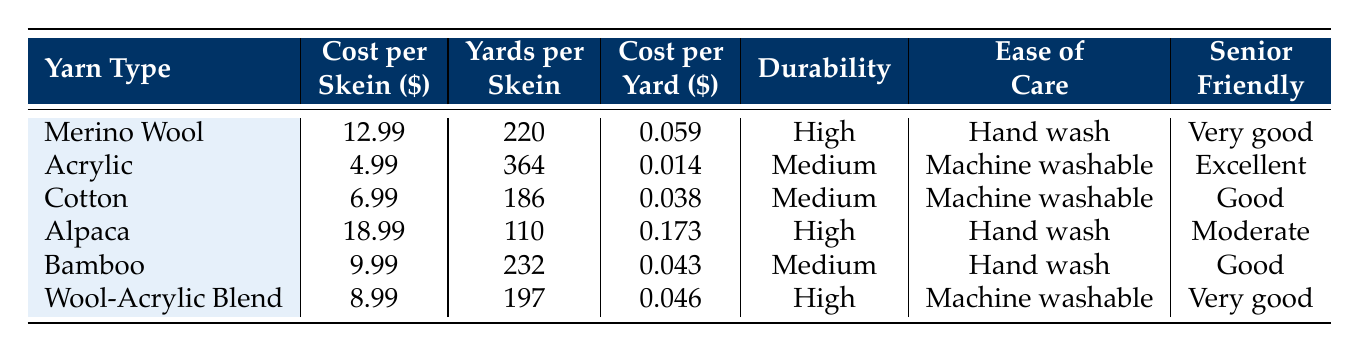What is the cost per skein of Merino Wool? The table lists the cost per skein of Merino Wool as 12.99.
Answer: 12.99 Which yarn type has the highest cost per yard? To determine the highest cost per yard, we can compare the cost per yard for all yarn types listed in the table. Alpaca has the highest cost per yard at 0.173.
Answer: Alpaca How many yards does a skein of Acrylic provide? Directly from the table, it states that a skein of Acrylic provides 364 yards.
Answer: 364 Is Bamboo less durable than Merino Wool? The durability of Bamboo is rated as Medium, while Merino Wool is rated as High. Therefore, Bamboo is indeed less durable than Merino Wool.
Answer: Yes What is the average cost per skein for the yarn types listed? To find the average cost per skein, we first sum the costs: (12.99 + 4.99 + 6.99 + 18.99 + 9.99 + 8.99) = 61.94, then divide by the number of yarn types (6): 61.94 / 6 = 10.32.
Answer: 10.32 Which yarn type is best for sweaters, and how many yards does it provide? From the table, Merino Wool is best for sweaters and provides 220 yards per skein.
Answer: Merino Wool, 220 yards How much cheaper is Acrylic per yard compared to Alpaca? The cost per yard for Acrylic is 0.014, and for Alpaca, it is 0.173. The difference is 0.173 - 0.014 = 0.159.
Answer: 0.159 Is Cotton recommended for winter garments? The table indicates that Cotton has "Low" warmth, implying it is not suitable for winter garments.
Answer: No Which yarn types are very senior-friendly? The table lists Merino Wool and Wool-Acrylic Blend as "Very good" senior-friendly types, while Acrylic is marked as "Excellent." Hence, three yarn types meet this criterion.
Answer: 3 types What is the cost difference between Wool-Acrylic Blend and Cotton per skein? The cost per skein of Wool-Acrylic Blend is 8.99 and that of Cotton is 6.99. The difference is 8.99 - 6.99 = 2.00.
Answer: 2.00 